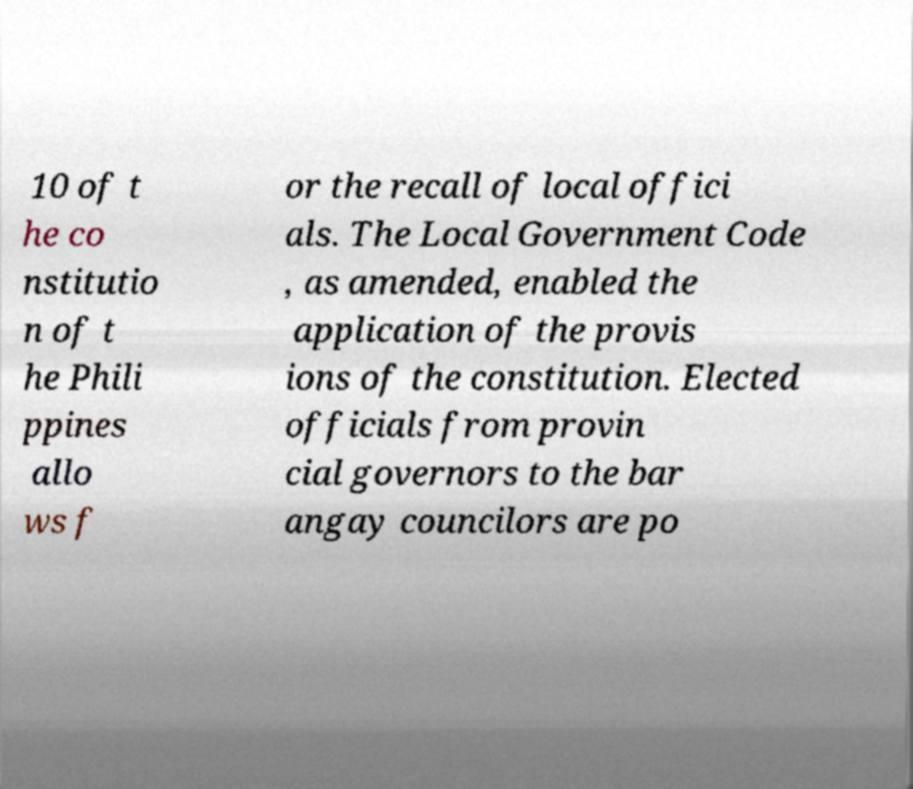Can you read and provide the text displayed in the image?This photo seems to have some interesting text. Can you extract and type it out for me? 10 of t he co nstitutio n of t he Phili ppines allo ws f or the recall of local offici als. The Local Government Code , as amended, enabled the application of the provis ions of the constitution. Elected officials from provin cial governors to the bar angay councilors are po 